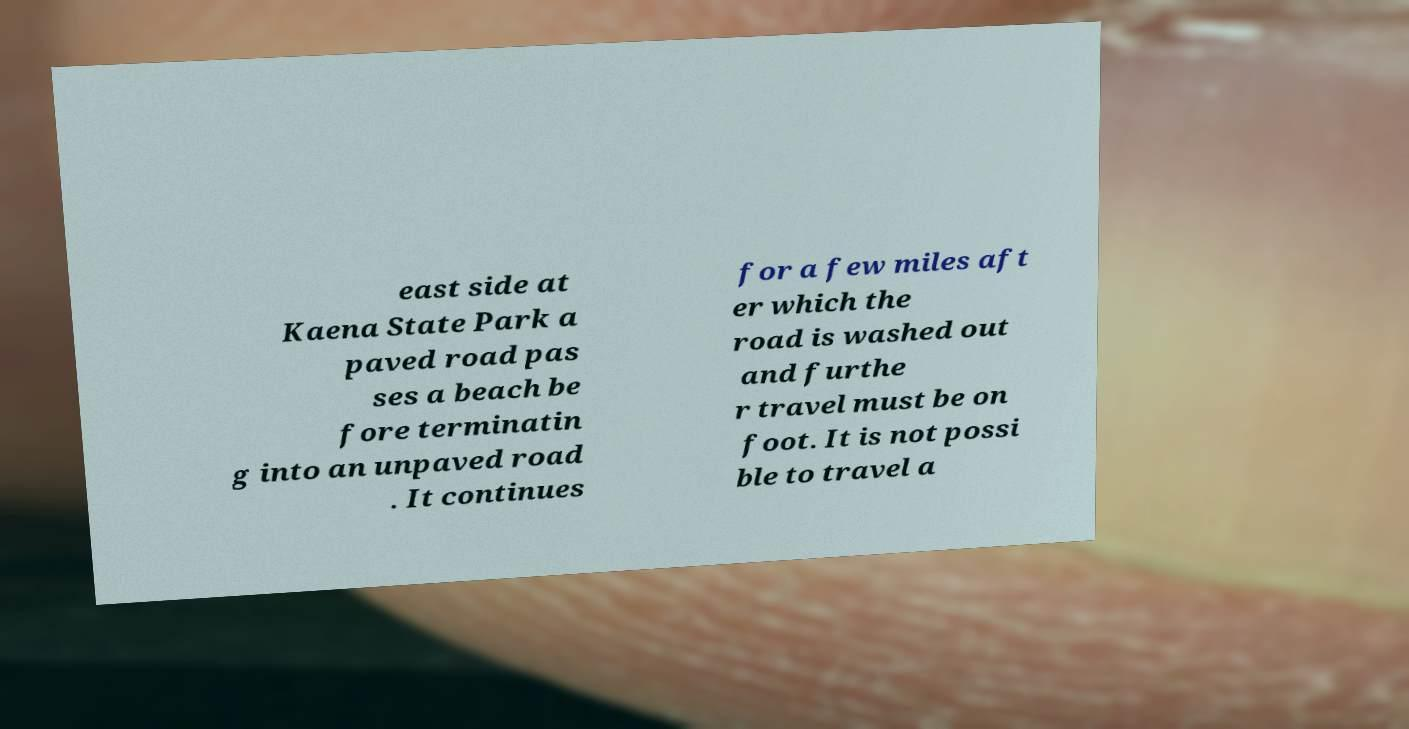What messages or text are displayed in this image? I need them in a readable, typed format. east side at Kaena State Park a paved road pas ses a beach be fore terminatin g into an unpaved road . It continues for a few miles aft er which the road is washed out and furthe r travel must be on foot. It is not possi ble to travel a 